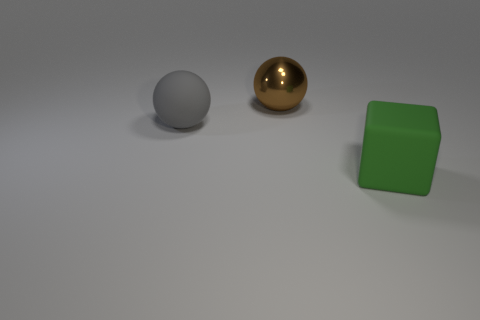Are there any other things that have the same material as the large brown sphere?
Your answer should be compact. No. Are there more cubes that are right of the large gray rubber thing than yellow metal things?
Your answer should be very brief. Yes. Do the brown sphere and the green cube have the same material?
Your answer should be very brief. No. How many things are either large objects left of the brown metal thing or big brown rubber cylinders?
Provide a succinct answer. 1. Are there the same number of gray matte balls that are on the left side of the brown thing and matte spheres to the left of the big green rubber object?
Make the answer very short. Yes. The other big thing that is the same shape as the metal object is what color?
Your answer should be compact. Gray. Are there any other things that have the same shape as the big metal thing?
Give a very brief answer. Yes. What is the size of the gray rubber object that is the same shape as the brown shiny object?
Provide a succinct answer. Large. What number of large green things are the same material as the gray thing?
Your response must be concise. 1. There is a matte object left of the big matte thing in front of the gray matte sphere; is there a big sphere to the right of it?
Ensure brevity in your answer.  Yes. 